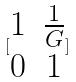<formula> <loc_0><loc_0><loc_500><loc_500>[ \begin{matrix} 1 & \frac { 1 } { G } \\ 0 & 1 \end{matrix} ]</formula> 